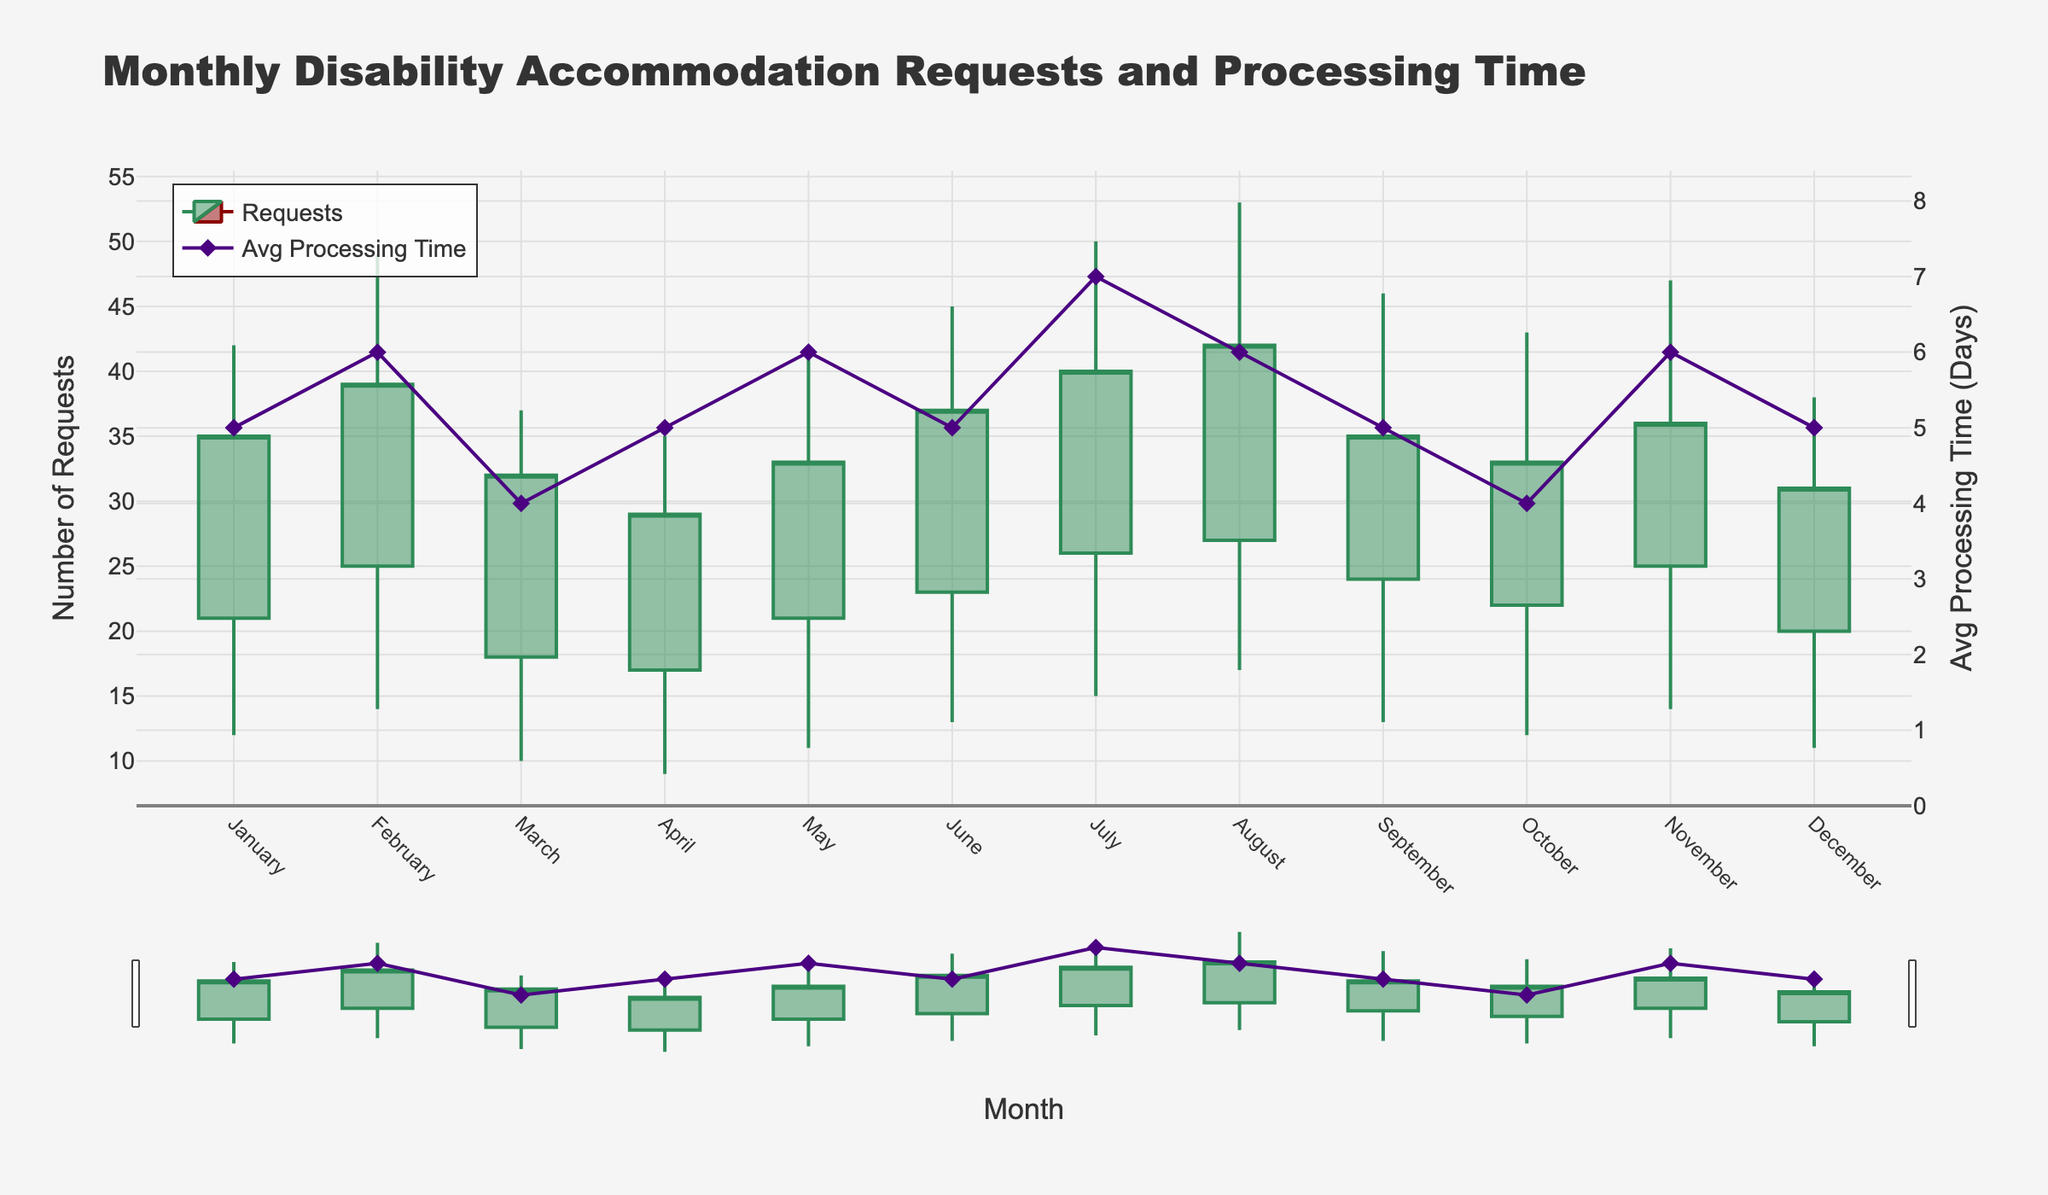What's the title of the figure? The title of the figure is usually displayed prominently at the top. In this case, it reads "Monthly Disability Accommodation Requests and Processing Time".
Answer: Monthly Disability Accommodation Requests and Processing Time What do the green and red candlesticks represent? The color of the candlesticks indicates the type of change. Green candlesticks show an increase in the number of requests (i.e., Close Requests are higher than Open Requests), while red candlesticks show a decrease (i.e., Close Requests are lower than Open Requests).
Answer: Green candlesticks represent an increase, red candlesticks represent a decrease In which month was the average processing time the highest? Look for the scatter plot with diamond markers and check which month corresponds to the highest y-value. July shows the highest average processing time with a value of 7 days.
Answer: July What was the maximum number of requests in August? Locate the highest point of the candlestick in August. The maximum requests value for August is 53.
Answer: 53 Which month had the lowest number of minimum requests? Locate the lowest point of any candlestick and identify the month associated with it. April has the lowest minimum requests, with a value of 9.
Answer: April Compare the number of Close Requests in February and September. Which month saw more requests closed? Compare the Close Requests value for both months. February has 39 Close Requests, whereas September has 35 Close Requests. Therefore, February saw more requests closed.
Answer: February How does the average processing time in March compare to that in October? Look at the diamond markers for March and October and compare their y-values. Both have an average processing time of 4 days, so they are equal.
Answer: Equal What is the total number of Open Requests from January to June? Add the Open Requests values from January to June: 21 + 25 + 18 + 17 + 21 + 23 = 125.
Answer: 125 What is the difference in the minimum number of requests between January and November? Subtract the minimum number of requests in January from November: 14 - 12 = 2.
Answer: 2 Identify the month with the highest Close Requests and average processing time combined. Calculate the sum of Close Requests and average processing time for each month and identify the highest combined value. July has the highest Close Requests and average processing time combined (40 + 7 = 47).
Answer: July 